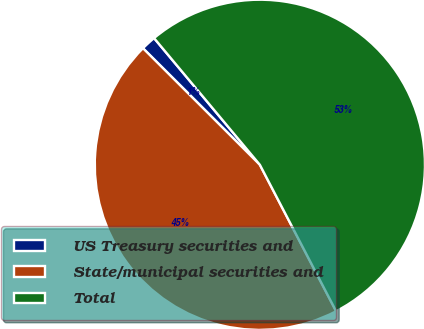Convert chart to OTSL. <chart><loc_0><loc_0><loc_500><loc_500><pie_chart><fcel>US Treasury securities and<fcel>State/municipal securities and<fcel>Total<nl><fcel>1.45%<fcel>45.12%<fcel>53.44%<nl></chart> 